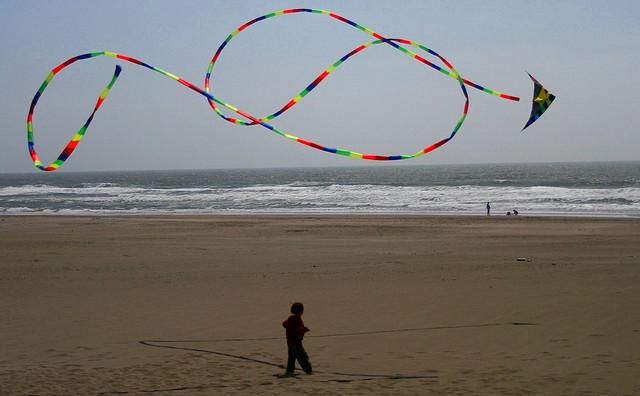What is unique about this kite? tail 